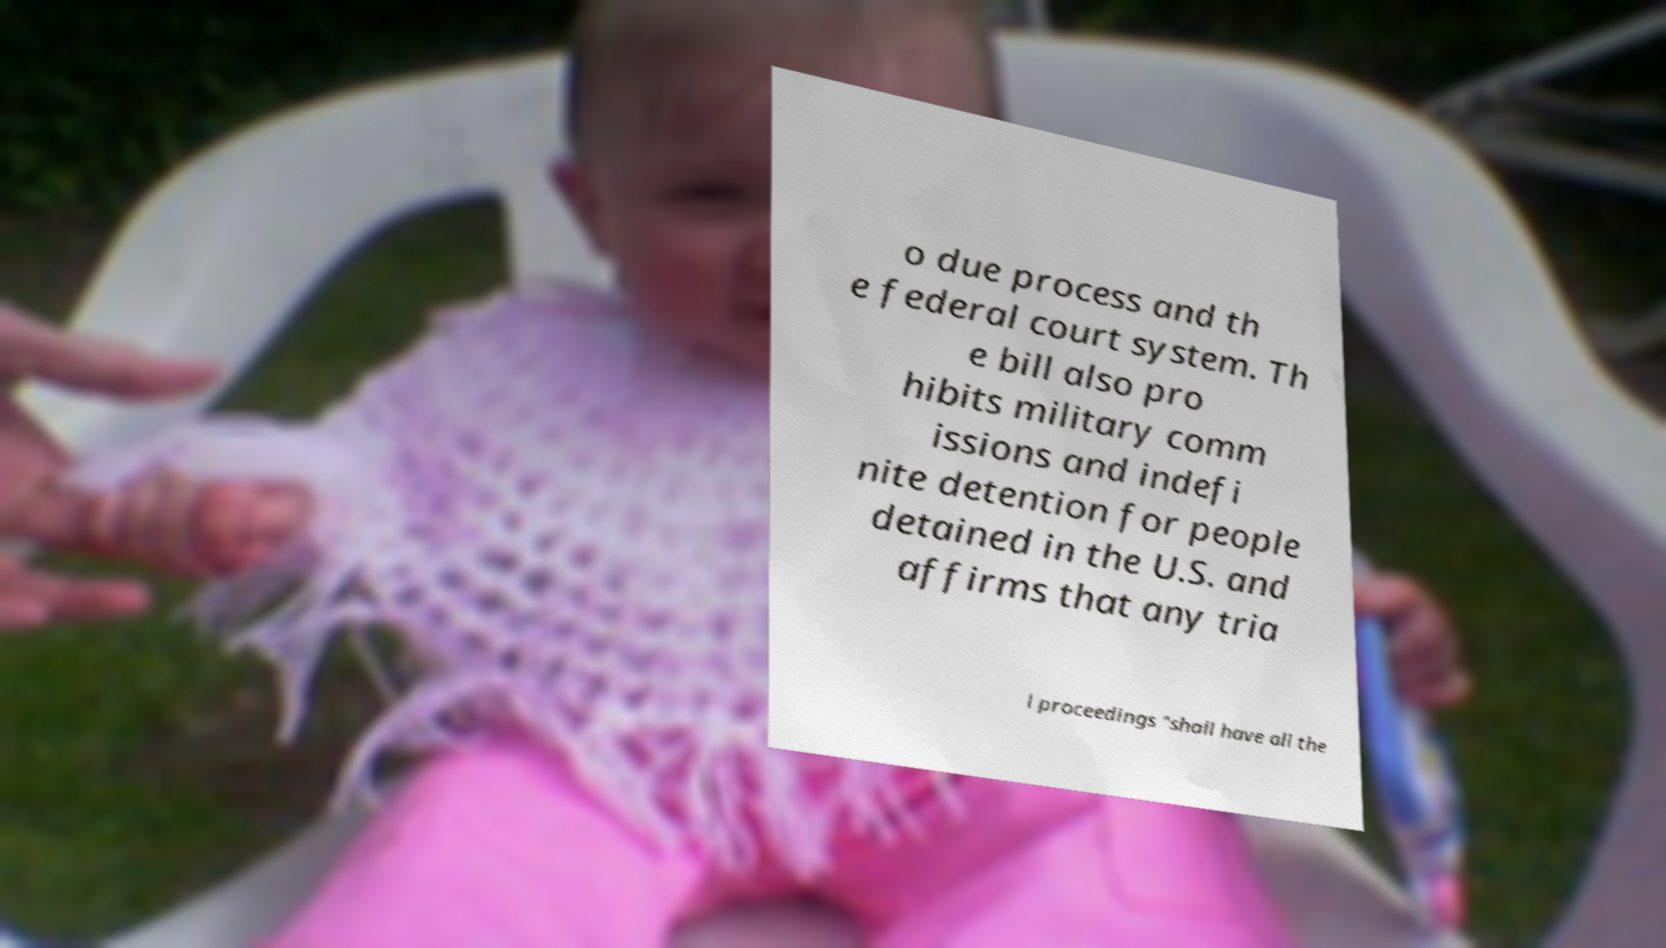Could you extract and type out the text from this image? o due process and th e federal court system. Th e bill also pro hibits military comm issions and indefi nite detention for people detained in the U.S. and affirms that any tria l proceedings "shall have all the 